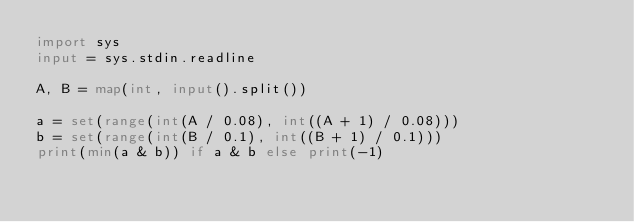Convert code to text. <code><loc_0><loc_0><loc_500><loc_500><_Python_>import sys
input = sys.stdin.readline

A, B = map(int, input().split())

a = set(range(int(A / 0.08), int((A + 1) / 0.08)))
b = set(range(int(B / 0.1), int((B + 1) / 0.1)))
print(min(a & b)) if a & b else print(-1)
</code> 